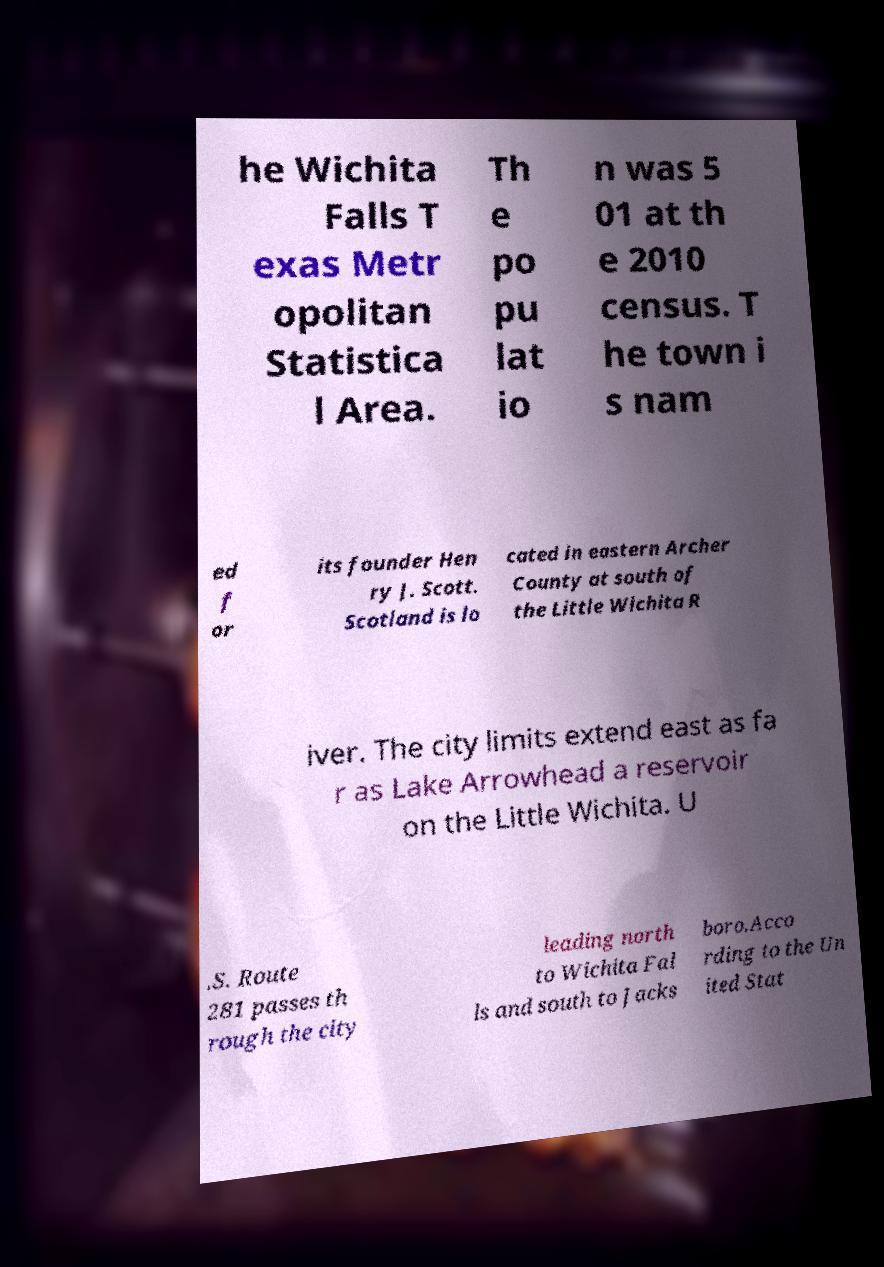Can you accurately transcribe the text from the provided image for me? he Wichita Falls T exas Metr opolitan Statistica l Area. Th e po pu lat io n was 5 01 at th e 2010 census. T he town i s nam ed f or its founder Hen ry J. Scott. Scotland is lo cated in eastern Archer County at south of the Little Wichita R iver. The city limits extend east as fa r as Lake Arrowhead a reservoir on the Little Wichita. U .S. Route 281 passes th rough the city leading north to Wichita Fal ls and south to Jacks boro.Acco rding to the Un ited Stat 